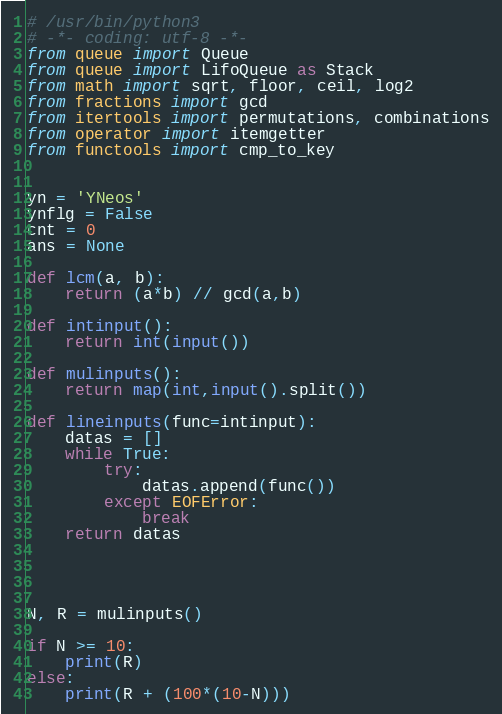<code> <loc_0><loc_0><loc_500><loc_500><_Python_># /usr/bin/python3
# -*- coding: utf-8 -*-
from queue import Queue
from queue import LifoQueue as Stack
from math import sqrt, floor, ceil, log2
from fractions import gcd
from itertools import permutations, combinations
from operator import itemgetter
from functools import cmp_to_key


yn = 'YNeos'
ynflg = False
cnt = 0
ans = None

def lcm(a, b):
    return (a*b) // gcd(a,b)

def intinput():
    return int(input())

def mulinputs():
    return map(int,input().split())

def lineinputs(func=intinput):
    datas = []
    while True:
        try:
            datas.append(func())
        except EOFError:
            break
    return datas




N, R = mulinputs()

if N >= 10:
    print(R)
else:
    print(R + (100*(10-N)))


</code> 